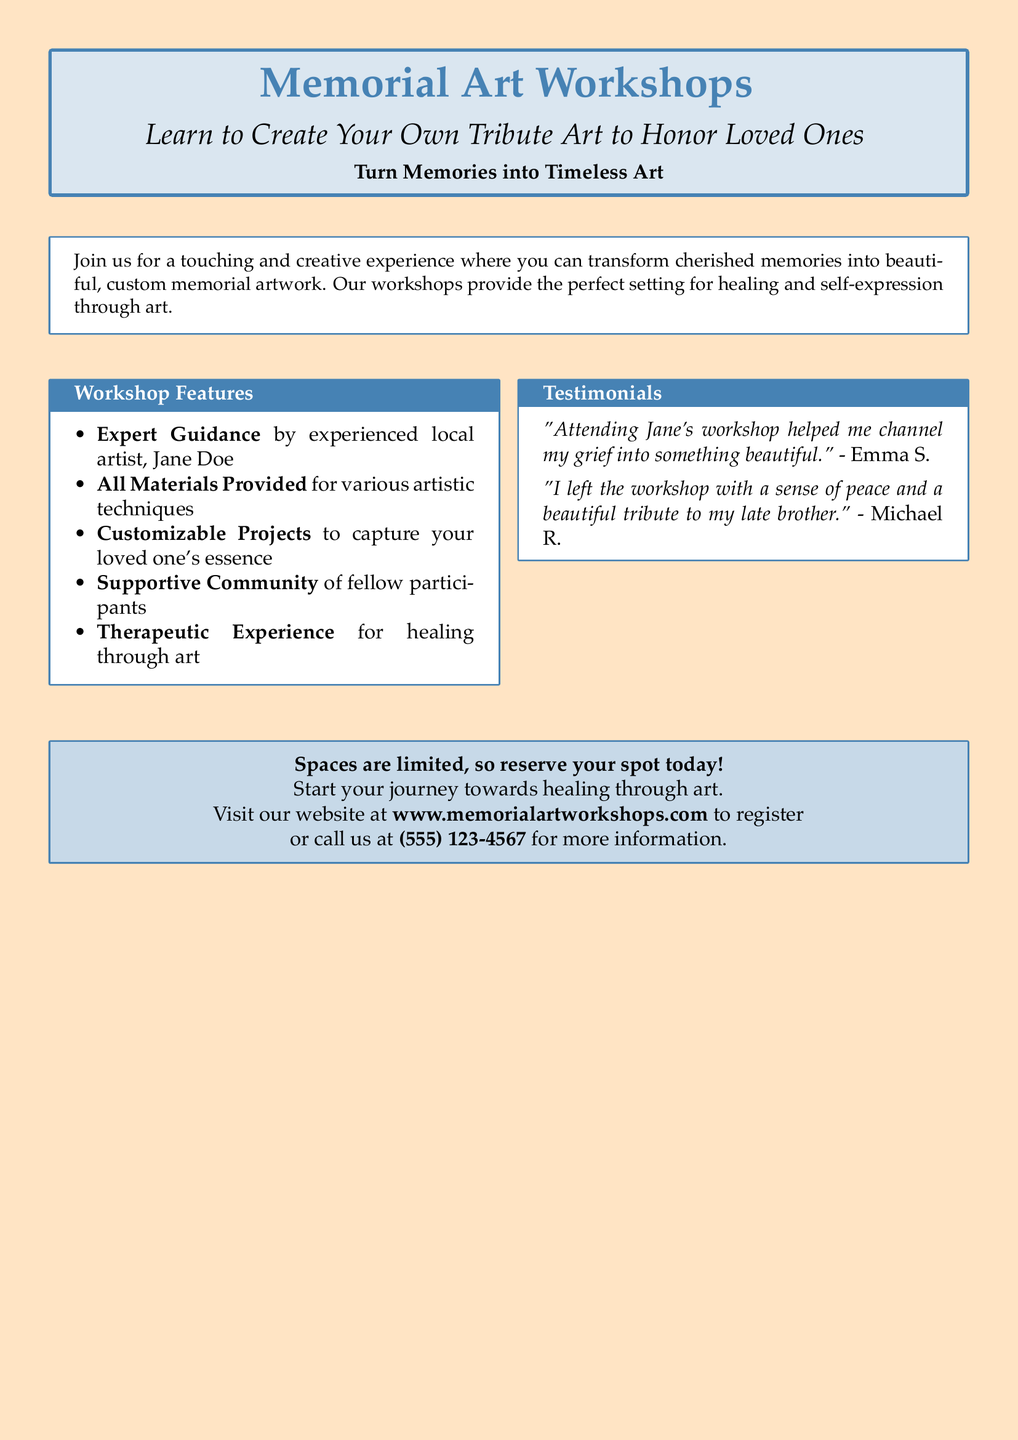What is the title of the workshops? The title of the workshops is stated at the top of the advertisement, prominently featured as "Memorial Art Workshops."
Answer: Memorial Art Workshops Who is the instructor of the workshops? The advertisement provides the name of the instructor under the workshop features, specifying that it is "experienced local artist, Jane Doe."
Answer: Jane Doe What type of experience do the workshops provide? The workshops are described as offering a "Therapeutic Experience" for participants, emphasizing the healing aspect through art.
Answer: Therapeutic Experience How can participants register for the workshops? The advertisement advises readers to visit the specified "website" or call the provided phone number to register or for more information.
Answer: www.memorialartworkshops.com What is one benefit mentioned that participants may experience? The testimonials indicate that participants can achieve a "sense of peace" and channel their grief into art, illustrating the emotional benefits of attending the workshops.
Answer: Sense of peace How many testimonies are featured in the document? The document includes two testimonials from participants highlighting their experiences in the workshop.
Answer: Two What is one of the provided materials for the workshops? The document states that "All Materials Provided" for various artistic techniques, indicating that participants will have all necessary supplies at hand.
Answer: All Materials Provided What is the color used for the page background? The advertisement specifies that the background color is "secondcolor," which corresponds to an RGB value of {255,228,196}.
Answer: secondcolor What is the maximum number of participants mentioned? The document hints that "Spaces are limited," but does not provide a specific number; it implies that there is a cap on participants.
Answer: Limited 